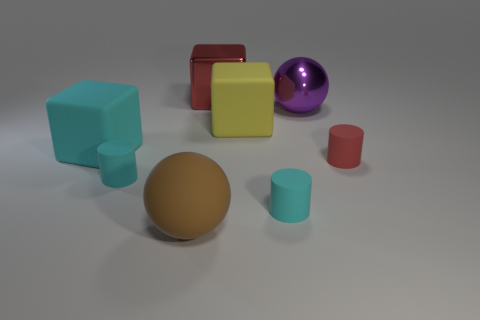How many objects are red things or big cyan rubber things?
Offer a very short reply. 3. What is the color of the metallic thing that is the same size as the red metallic block?
Your response must be concise. Purple. How many objects are things to the right of the cyan rubber cube or spheres?
Your answer should be compact. 7. How many other objects are the same size as the purple thing?
Your answer should be compact. 4. There is a cyan matte cylinder that is on the left side of the red metal block; what is its size?
Offer a very short reply. Small. What shape is the red thing that is made of the same material as the brown sphere?
Keep it short and to the point. Cylinder. Is there any other thing that is the same color as the shiny block?
Your response must be concise. Yes. The small thing that is right of the metal object in front of the large red metallic block is what color?
Offer a very short reply. Red. How many large things are yellow cubes or metallic balls?
Give a very brief answer. 2. What is the material of the cyan object that is the same shape as the large red metal object?
Your response must be concise. Rubber. 